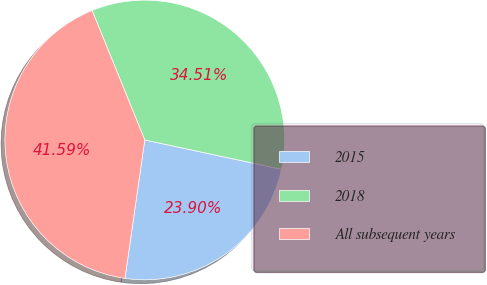Convert chart. <chart><loc_0><loc_0><loc_500><loc_500><pie_chart><fcel>2015<fcel>2018<fcel>All subsequent years<nl><fcel>23.9%<fcel>34.51%<fcel>41.59%<nl></chart> 